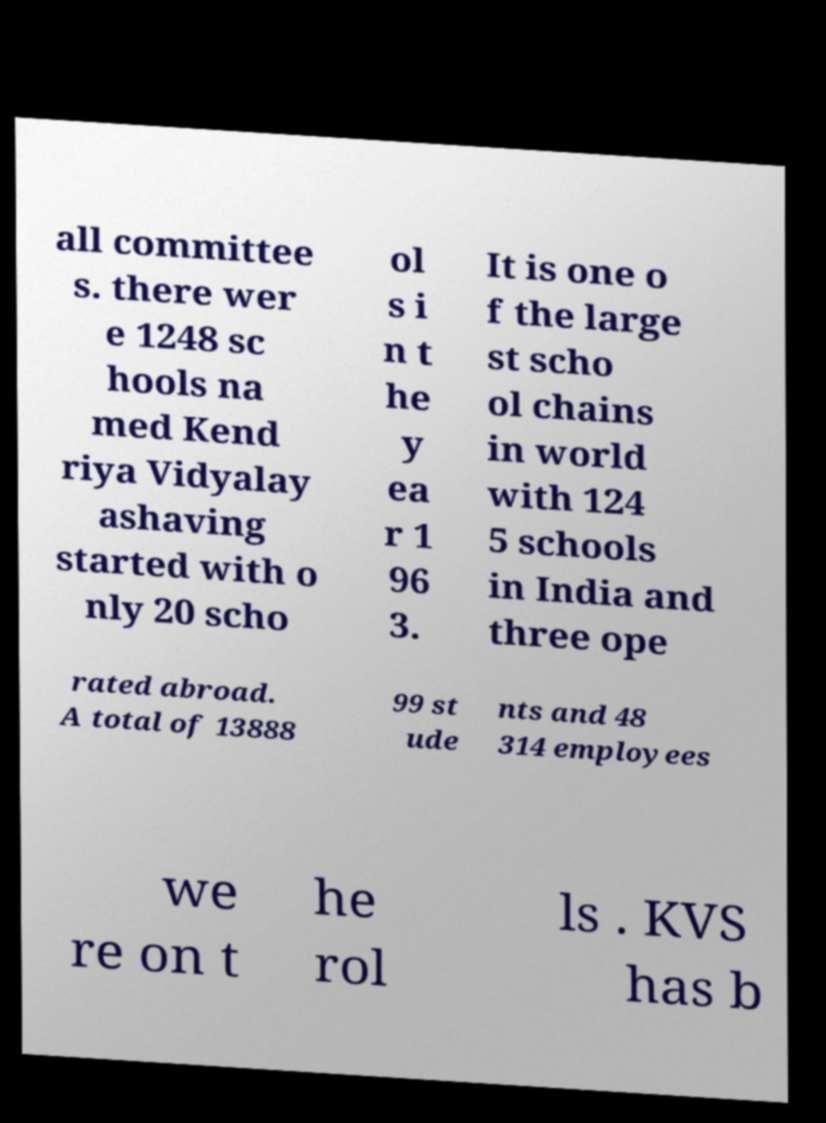Can you accurately transcribe the text from the provided image for me? all committee s. there wer e 1248 sc hools na med Kend riya Vidyalay ashaving started with o nly 20 scho ol s i n t he y ea r 1 96 3. It is one o f the large st scho ol chains in world with 124 5 schools in India and three ope rated abroad. A total of 13888 99 st ude nts and 48 314 employees we re on t he rol ls . KVS has b 